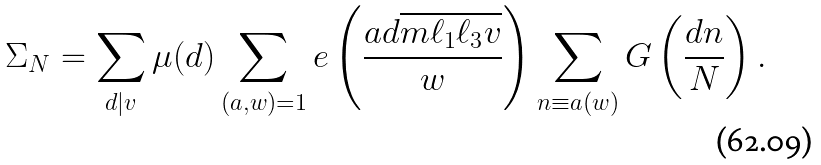<formula> <loc_0><loc_0><loc_500><loc_500>\Sigma _ { N } & = \sum _ { d | v } \mu ( d ) \sum _ { ( a , w ) = 1 } e \left ( \frac { a d \overline { m \ell _ { 1 } \ell _ { 3 } v } } { w } \right ) \sum _ { n \equiv a ( w ) } G \left ( \frac { d n } { N } \right ) .</formula> 